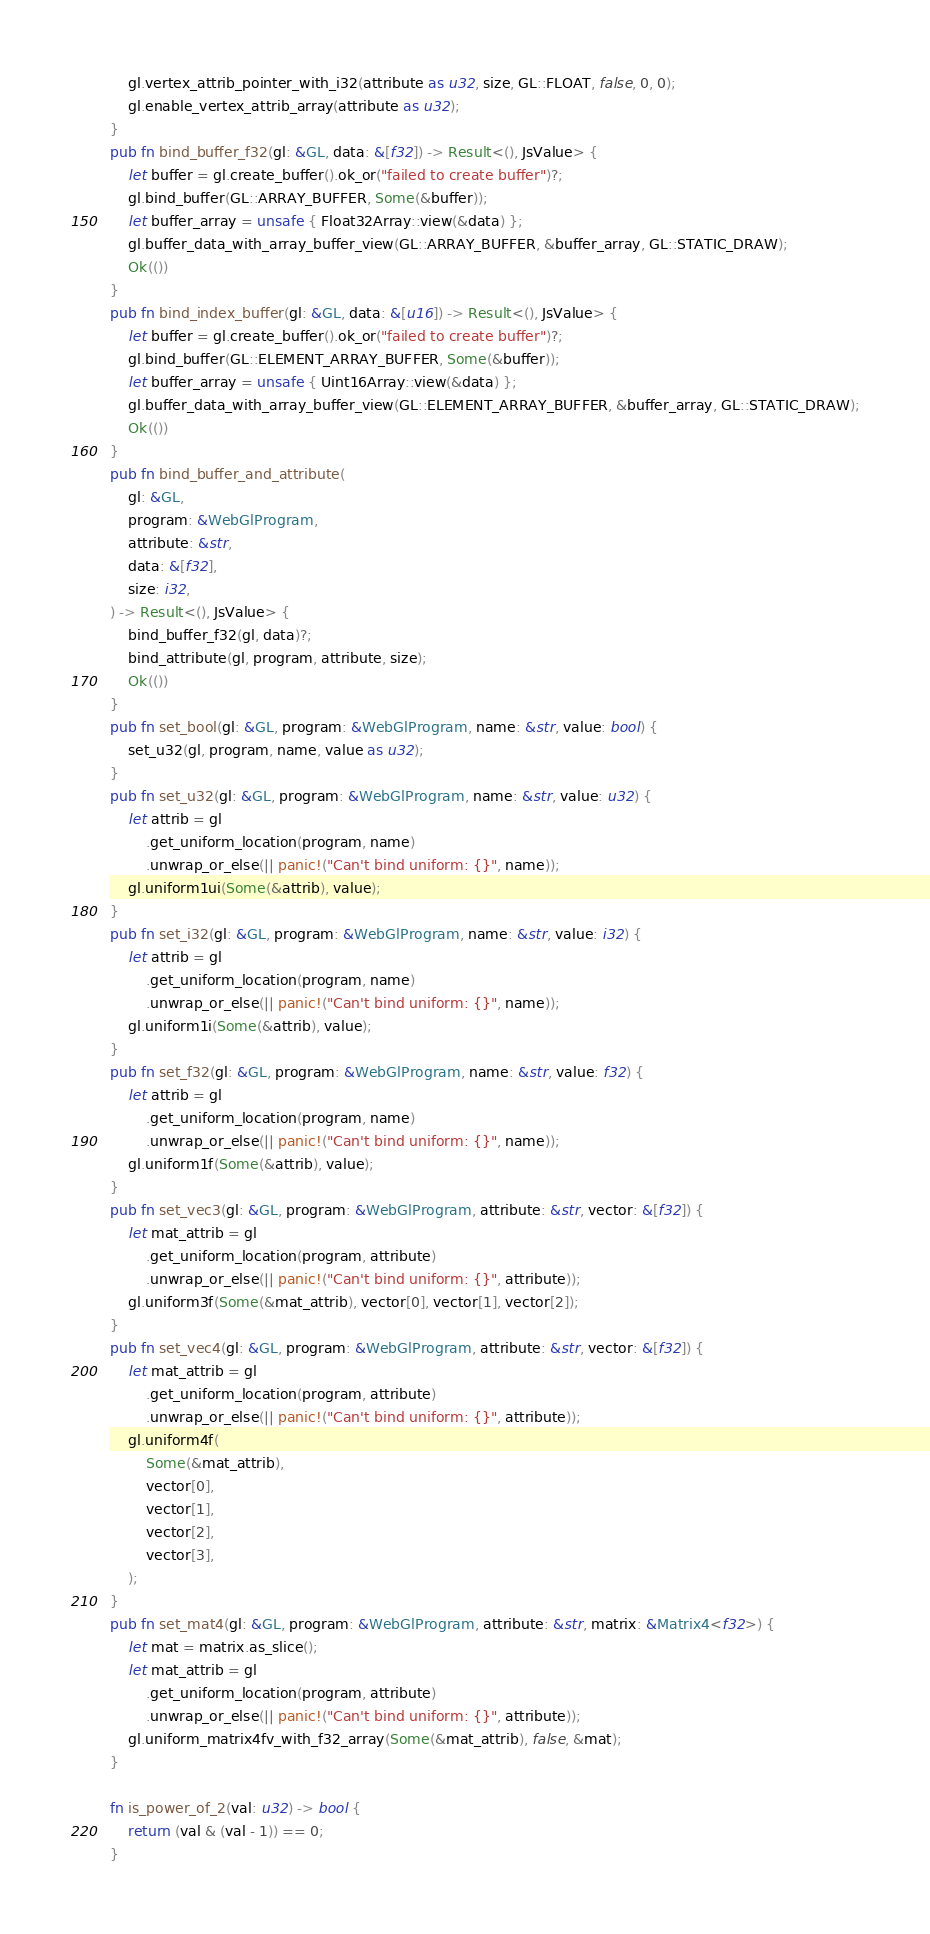Convert code to text. <code><loc_0><loc_0><loc_500><loc_500><_Rust_>    gl.vertex_attrib_pointer_with_i32(attribute as u32, size, GL::FLOAT, false, 0, 0);
    gl.enable_vertex_attrib_array(attribute as u32);
}
pub fn bind_buffer_f32(gl: &GL, data: &[f32]) -> Result<(), JsValue> {
    let buffer = gl.create_buffer().ok_or("failed to create buffer")?;
    gl.bind_buffer(GL::ARRAY_BUFFER, Some(&buffer));
    let buffer_array = unsafe { Float32Array::view(&data) };
    gl.buffer_data_with_array_buffer_view(GL::ARRAY_BUFFER, &buffer_array, GL::STATIC_DRAW);
    Ok(())
}
pub fn bind_index_buffer(gl: &GL, data: &[u16]) -> Result<(), JsValue> {
    let buffer = gl.create_buffer().ok_or("failed to create buffer")?;
    gl.bind_buffer(GL::ELEMENT_ARRAY_BUFFER, Some(&buffer));
    let buffer_array = unsafe { Uint16Array::view(&data) };
    gl.buffer_data_with_array_buffer_view(GL::ELEMENT_ARRAY_BUFFER, &buffer_array, GL::STATIC_DRAW);
    Ok(())
}
pub fn bind_buffer_and_attribute(
    gl: &GL,
    program: &WebGlProgram,
    attribute: &str,
    data: &[f32],
    size: i32,
) -> Result<(), JsValue> {
    bind_buffer_f32(gl, data)?;
    bind_attribute(gl, program, attribute, size);
    Ok(())
}
pub fn set_bool(gl: &GL, program: &WebGlProgram, name: &str, value: bool) {
    set_u32(gl, program, name, value as u32);
}
pub fn set_u32(gl: &GL, program: &WebGlProgram, name: &str, value: u32) {
    let attrib = gl
        .get_uniform_location(program, name)
        .unwrap_or_else(|| panic!("Can't bind uniform: {}", name));
    gl.uniform1ui(Some(&attrib), value);
}
pub fn set_i32(gl: &GL, program: &WebGlProgram, name: &str, value: i32) {
    let attrib = gl
        .get_uniform_location(program, name)
        .unwrap_or_else(|| panic!("Can't bind uniform: {}", name));
    gl.uniform1i(Some(&attrib), value);
}
pub fn set_f32(gl: &GL, program: &WebGlProgram, name: &str, value: f32) {
    let attrib = gl
        .get_uniform_location(program, name)
        .unwrap_or_else(|| panic!("Can't bind uniform: {}", name));
    gl.uniform1f(Some(&attrib), value);
}
pub fn set_vec3(gl: &GL, program: &WebGlProgram, attribute: &str, vector: &[f32]) {
    let mat_attrib = gl
        .get_uniform_location(program, attribute)
        .unwrap_or_else(|| panic!("Can't bind uniform: {}", attribute));
    gl.uniform3f(Some(&mat_attrib), vector[0], vector[1], vector[2]);
}
pub fn set_vec4(gl: &GL, program: &WebGlProgram, attribute: &str, vector: &[f32]) {
    let mat_attrib = gl
        .get_uniform_location(program, attribute)
        .unwrap_or_else(|| panic!("Can't bind uniform: {}", attribute));
    gl.uniform4f(
        Some(&mat_attrib),
        vector[0],
        vector[1],
        vector[2],
        vector[3],
    );
}
pub fn set_mat4(gl: &GL, program: &WebGlProgram, attribute: &str, matrix: &Matrix4<f32>) {
    let mat = matrix.as_slice();
    let mat_attrib = gl
        .get_uniform_location(program, attribute)
        .unwrap_or_else(|| panic!("Can't bind uniform: {}", attribute));
    gl.uniform_matrix4fv_with_f32_array(Some(&mat_attrib), false, &mat);
}

fn is_power_of_2(val: u32) -> bool {
    return (val & (val - 1)) == 0;
}
</code> 